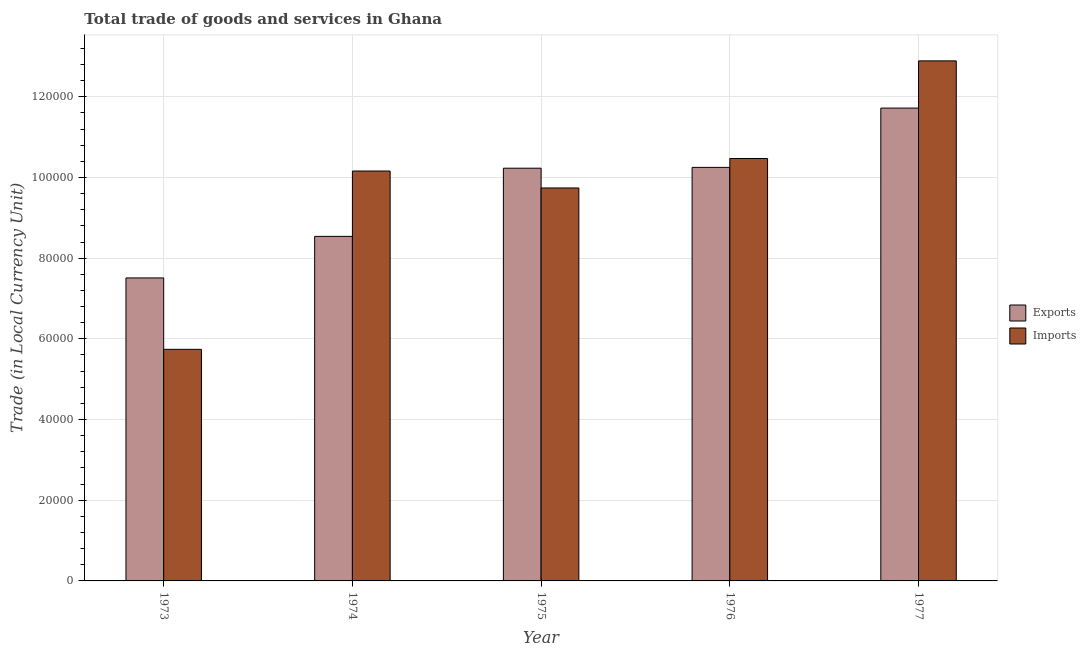How many groups of bars are there?
Provide a short and direct response. 5. Are the number of bars per tick equal to the number of legend labels?
Make the answer very short. Yes. How many bars are there on the 2nd tick from the right?
Your answer should be compact. 2. What is the export of goods and services in 1975?
Ensure brevity in your answer.  1.02e+05. Across all years, what is the maximum export of goods and services?
Give a very brief answer. 1.17e+05. Across all years, what is the minimum imports of goods and services?
Offer a terse response. 5.74e+04. What is the total imports of goods and services in the graph?
Your answer should be very brief. 4.90e+05. What is the difference between the imports of goods and services in 1973 and that in 1977?
Your answer should be compact. -7.15e+04. What is the difference between the imports of goods and services in 1973 and the export of goods and services in 1976?
Offer a very short reply. -4.73e+04. What is the average export of goods and services per year?
Your answer should be compact. 9.65e+04. What is the ratio of the export of goods and services in 1974 to that in 1977?
Your answer should be very brief. 0.73. What is the difference between the highest and the second highest imports of goods and services?
Ensure brevity in your answer.  2.42e+04. What is the difference between the highest and the lowest export of goods and services?
Offer a very short reply. 4.21e+04. In how many years, is the export of goods and services greater than the average export of goods and services taken over all years?
Provide a succinct answer. 3. What does the 2nd bar from the left in 1973 represents?
Provide a short and direct response. Imports. What does the 1st bar from the right in 1976 represents?
Keep it short and to the point. Imports. How many bars are there?
Ensure brevity in your answer.  10. Are all the bars in the graph horizontal?
Ensure brevity in your answer.  No. Does the graph contain any zero values?
Offer a very short reply. No. Does the graph contain grids?
Offer a terse response. Yes. Where does the legend appear in the graph?
Give a very brief answer. Center right. How many legend labels are there?
Offer a very short reply. 2. How are the legend labels stacked?
Your response must be concise. Vertical. What is the title of the graph?
Your response must be concise. Total trade of goods and services in Ghana. What is the label or title of the Y-axis?
Your response must be concise. Trade (in Local Currency Unit). What is the Trade (in Local Currency Unit) in Exports in 1973?
Provide a succinct answer. 7.51e+04. What is the Trade (in Local Currency Unit) in Imports in 1973?
Offer a terse response. 5.74e+04. What is the Trade (in Local Currency Unit) in Exports in 1974?
Keep it short and to the point. 8.54e+04. What is the Trade (in Local Currency Unit) of Imports in 1974?
Offer a very short reply. 1.02e+05. What is the Trade (in Local Currency Unit) of Exports in 1975?
Your answer should be very brief. 1.02e+05. What is the Trade (in Local Currency Unit) of Imports in 1975?
Give a very brief answer. 9.74e+04. What is the Trade (in Local Currency Unit) of Exports in 1976?
Ensure brevity in your answer.  1.02e+05. What is the Trade (in Local Currency Unit) of Imports in 1976?
Your answer should be compact. 1.05e+05. What is the Trade (in Local Currency Unit) in Exports in 1977?
Offer a very short reply. 1.17e+05. What is the Trade (in Local Currency Unit) of Imports in 1977?
Provide a succinct answer. 1.29e+05. Across all years, what is the maximum Trade (in Local Currency Unit) of Exports?
Provide a short and direct response. 1.17e+05. Across all years, what is the maximum Trade (in Local Currency Unit) in Imports?
Make the answer very short. 1.29e+05. Across all years, what is the minimum Trade (in Local Currency Unit) of Exports?
Make the answer very short. 7.51e+04. Across all years, what is the minimum Trade (in Local Currency Unit) in Imports?
Offer a very short reply. 5.74e+04. What is the total Trade (in Local Currency Unit) in Exports in the graph?
Offer a very short reply. 4.82e+05. What is the difference between the Trade (in Local Currency Unit) in Exports in 1973 and that in 1974?
Your response must be concise. -1.03e+04. What is the difference between the Trade (in Local Currency Unit) of Imports in 1973 and that in 1974?
Provide a succinct answer. -4.42e+04. What is the difference between the Trade (in Local Currency Unit) in Exports in 1973 and that in 1975?
Make the answer very short. -2.72e+04. What is the difference between the Trade (in Local Currency Unit) in Imports in 1973 and that in 1975?
Give a very brief answer. -4.00e+04. What is the difference between the Trade (in Local Currency Unit) of Exports in 1973 and that in 1976?
Provide a succinct answer. -2.74e+04. What is the difference between the Trade (in Local Currency Unit) in Imports in 1973 and that in 1976?
Give a very brief answer. -4.73e+04. What is the difference between the Trade (in Local Currency Unit) in Exports in 1973 and that in 1977?
Keep it short and to the point. -4.21e+04. What is the difference between the Trade (in Local Currency Unit) of Imports in 1973 and that in 1977?
Ensure brevity in your answer.  -7.15e+04. What is the difference between the Trade (in Local Currency Unit) in Exports in 1974 and that in 1975?
Your answer should be compact. -1.69e+04. What is the difference between the Trade (in Local Currency Unit) in Imports in 1974 and that in 1975?
Ensure brevity in your answer.  4200. What is the difference between the Trade (in Local Currency Unit) of Exports in 1974 and that in 1976?
Provide a short and direct response. -1.71e+04. What is the difference between the Trade (in Local Currency Unit) of Imports in 1974 and that in 1976?
Offer a very short reply. -3100. What is the difference between the Trade (in Local Currency Unit) in Exports in 1974 and that in 1977?
Provide a succinct answer. -3.18e+04. What is the difference between the Trade (in Local Currency Unit) of Imports in 1974 and that in 1977?
Your answer should be compact. -2.73e+04. What is the difference between the Trade (in Local Currency Unit) in Exports in 1975 and that in 1976?
Give a very brief answer. -200. What is the difference between the Trade (in Local Currency Unit) in Imports in 1975 and that in 1976?
Your response must be concise. -7300. What is the difference between the Trade (in Local Currency Unit) of Exports in 1975 and that in 1977?
Ensure brevity in your answer.  -1.49e+04. What is the difference between the Trade (in Local Currency Unit) in Imports in 1975 and that in 1977?
Your answer should be very brief. -3.15e+04. What is the difference between the Trade (in Local Currency Unit) in Exports in 1976 and that in 1977?
Your answer should be very brief. -1.47e+04. What is the difference between the Trade (in Local Currency Unit) in Imports in 1976 and that in 1977?
Offer a terse response. -2.42e+04. What is the difference between the Trade (in Local Currency Unit) in Exports in 1973 and the Trade (in Local Currency Unit) in Imports in 1974?
Keep it short and to the point. -2.65e+04. What is the difference between the Trade (in Local Currency Unit) of Exports in 1973 and the Trade (in Local Currency Unit) of Imports in 1975?
Offer a terse response. -2.23e+04. What is the difference between the Trade (in Local Currency Unit) of Exports in 1973 and the Trade (in Local Currency Unit) of Imports in 1976?
Provide a short and direct response. -2.96e+04. What is the difference between the Trade (in Local Currency Unit) in Exports in 1973 and the Trade (in Local Currency Unit) in Imports in 1977?
Offer a very short reply. -5.38e+04. What is the difference between the Trade (in Local Currency Unit) in Exports in 1974 and the Trade (in Local Currency Unit) in Imports in 1975?
Provide a succinct answer. -1.20e+04. What is the difference between the Trade (in Local Currency Unit) of Exports in 1974 and the Trade (in Local Currency Unit) of Imports in 1976?
Offer a terse response. -1.93e+04. What is the difference between the Trade (in Local Currency Unit) of Exports in 1974 and the Trade (in Local Currency Unit) of Imports in 1977?
Make the answer very short. -4.35e+04. What is the difference between the Trade (in Local Currency Unit) of Exports in 1975 and the Trade (in Local Currency Unit) of Imports in 1976?
Ensure brevity in your answer.  -2400. What is the difference between the Trade (in Local Currency Unit) in Exports in 1975 and the Trade (in Local Currency Unit) in Imports in 1977?
Ensure brevity in your answer.  -2.66e+04. What is the difference between the Trade (in Local Currency Unit) in Exports in 1976 and the Trade (in Local Currency Unit) in Imports in 1977?
Keep it short and to the point. -2.64e+04. What is the average Trade (in Local Currency Unit) of Exports per year?
Your response must be concise. 9.65e+04. What is the average Trade (in Local Currency Unit) of Imports per year?
Provide a short and direct response. 9.80e+04. In the year 1973, what is the difference between the Trade (in Local Currency Unit) of Exports and Trade (in Local Currency Unit) of Imports?
Ensure brevity in your answer.  1.77e+04. In the year 1974, what is the difference between the Trade (in Local Currency Unit) in Exports and Trade (in Local Currency Unit) in Imports?
Offer a terse response. -1.62e+04. In the year 1975, what is the difference between the Trade (in Local Currency Unit) of Exports and Trade (in Local Currency Unit) of Imports?
Offer a very short reply. 4900. In the year 1976, what is the difference between the Trade (in Local Currency Unit) in Exports and Trade (in Local Currency Unit) in Imports?
Ensure brevity in your answer.  -2200. In the year 1977, what is the difference between the Trade (in Local Currency Unit) in Exports and Trade (in Local Currency Unit) in Imports?
Provide a short and direct response. -1.17e+04. What is the ratio of the Trade (in Local Currency Unit) of Exports in 1973 to that in 1974?
Make the answer very short. 0.88. What is the ratio of the Trade (in Local Currency Unit) of Imports in 1973 to that in 1974?
Offer a terse response. 0.56. What is the ratio of the Trade (in Local Currency Unit) of Exports in 1973 to that in 1975?
Provide a short and direct response. 0.73. What is the ratio of the Trade (in Local Currency Unit) in Imports in 1973 to that in 1975?
Provide a succinct answer. 0.59. What is the ratio of the Trade (in Local Currency Unit) in Exports in 1973 to that in 1976?
Your answer should be compact. 0.73. What is the ratio of the Trade (in Local Currency Unit) of Imports in 1973 to that in 1976?
Offer a very short reply. 0.55. What is the ratio of the Trade (in Local Currency Unit) of Exports in 1973 to that in 1977?
Offer a terse response. 0.64. What is the ratio of the Trade (in Local Currency Unit) of Imports in 1973 to that in 1977?
Your answer should be very brief. 0.45. What is the ratio of the Trade (in Local Currency Unit) in Exports in 1974 to that in 1975?
Provide a short and direct response. 0.83. What is the ratio of the Trade (in Local Currency Unit) of Imports in 1974 to that in 1975?
Ensure brevity in your answer.  1.04. What is the ratio of the Trade (in Local Currency Unit) in Exports in 1974 to that in 1976?
Keep it short and to the point. 0.83. What is the ratio of the Trade (in Local Currency Unit) in Imports in 1974 to that in 1976?
Your answer should be compact. 0.97. What is the ratio of the Trade (in Local Currency Unit) of Exports in 1974 to that in 1977?
Your response must be concise. 0.73. What is the ratio of the Trade (in Local Currency Unit) in Imports in 1974 to that in 1977?
Make the answer very short. 0.79. What is the ratio of the Trade (in Local Currency Unit) in Imports in 1975 to that in 1976?
Offer a terse response. 0.93. What is the ratio of the Trade (in Local Currency Unit) of Exports in 1975 to that in 1977?
Provide a short and direct response. 0.87. What is the ratio of the Trade (in Local Currency Unit) in Imports in 1975 to that in 1977?
Your answer should be compact. 0.76. What is the ratio of the Trade (in Local Currency Unit) in Exports in 1976 to that in 1977?
Give a very brief answer. 0.87. What is the ratio of the Trade (in Local Currency Unit) of Imports in 1976 to that in 1977?
Provide a succinct answer. 0.81. What is the difference between the highest and the second highest Trade (in Local Currency Unit) of Exports?
Provide a succinct answer. 1.47e+04. What is the difference between the highest and the second highest Trade (in Local Currency Unit) in Imports?
Keep it short and to the point. 2.42e+04. What is the difference between the highest and the lowest Trade (in Local Currency Unit) in Exports?
Provide a succinct answer. 4.21e+04. What is the difference between the highest and the lowest Trade (in Local Currency Unit) of Imports?
Your answer should be very brief. 7.15e+04. 